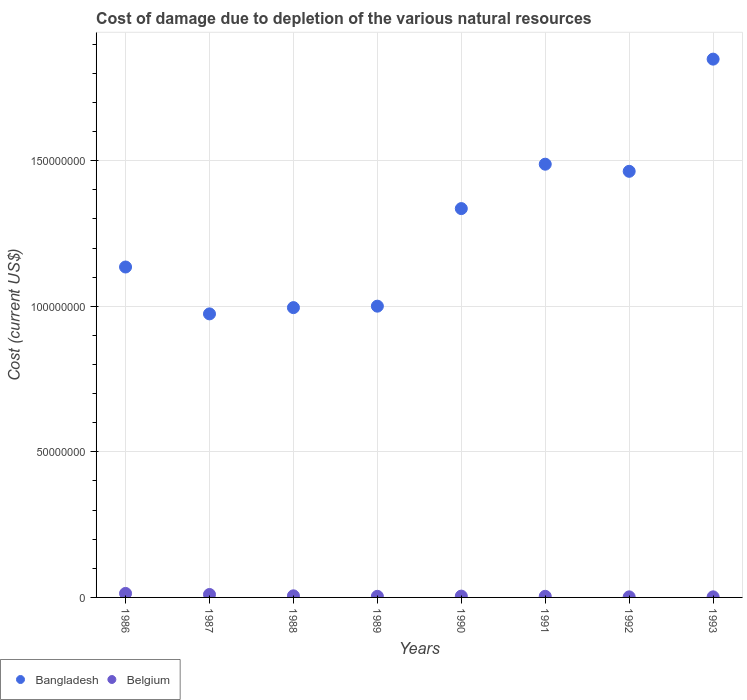How many different coloured dotlines are there?
Keep it short and to the point. 2. What is the cost of damage caused due to the depletion of various natural resources in Belgium in 1987?
Make the answer very short. 1.01e+06. Across all years, what is the maximum cost of damage caused due to the depletion of various natural resources in Belgium?
Your response must be concise. 1.37e+06. Across all years, what is the minimum cost of damage caused due to the depletion of various natural resources in Bangladesh?
Offer a very short reply. 9.74e+07. In which year was the cost of damage caused due to the depletion of various natural resources in Bangladesh maximum?
Your answer should be compact. 1993. What is the total cost of damage caused due to the depletion of various natural resources in Belgium in the graph?
Give a very brief answer. 4.54e+06. What is the difference between the cost of damage caused due to the depletion of various natural resources in Bangladesh in 1990 and that in 1992?
Make the answer very short. -1.28e+07. What is the difference between the cost of damage caused due to the depletion of various natural resources in Bangladesh in 1988 and the cost of damage caused due to the depletion of various natural resources in Belgium in 1987?
Make the answer very short. 9.85e+07. What is the average cost of damage caused due to the depletion of various natural resources in Belgium per year?
Your answer should be very brief. 5.68e+05. In the year 1987, what is the difference between the cost of damage caused due to the depletion of various natural resources in Bangladesh and cost of damage caused due to the depletion of various natural resources in Belgium?
Offer a very short reply. 9.64e+07. In how many years, is the cost of damage caused due to the depletion of various natural resources in Belgium greater than 170000000 US$?
Provide a short and direct response. 0. What is the ratio of the cost of damage caused due to the depletion of various natural resources in Bangladesh in 1986 to that in 1988?
Give a very brief answer. 1.14. Is the difference between the cost of damage caused due to the depletion of various natural resources in Bangladesh in 1991 and 1992 greater than the difference between the cost of damage caused due to the depletion of various natural resources in Belgium in 1991 and 1992?
Ensure brevity in your answer.  Yes. What is the difference between the highest and the second highest cost of damage caused due to the depletion of various natural resources in Bangladesh?
Keep it short and to the point. 3.61e+07. What is the difference between the highest and the lowest cost of damage caused due to the depletion of various natural resources in Bangladesh?
Your answer should be compact. 8.75e+07. In how many years, is the cost of damage caused due to the depletion of various natural resources in Belgium greater than the average cost of damage caused due to the depletion of various natural resources in Belgium taken over all years?
Give a very brief answer. 2. Is the sum of the cost of damage caused due to the depletion of various natural resources in Bangladesh in 1986 and 1987 greater than the maximum cost of damage caused due to the depletion of various natural resources in Belgium across all years?
Provide a short and direct response. Yes. Does the cost of damage caused due to the depletion of various natural resources in Bangladesh monotonically increase over the years?
Your answer should be very brief. No. What is the difference between two consecutive major ticks on the Y-axis?
Offer a very short reply. 5.00e+07. Are the values on the major ticks of Y-axis written in scientific E-notation?
Provide a succinct answer. No. What is the title of the graph?
Your answer should be compact. Cost of damage due to depletion of the various natural resources. What is the label or title of the X-axis?
Your response must be concise. Years. What is the label or title of the Y-axis?
Make the answer very short. Cost (current US$). What is the Cost (current US$) in Bangladesh in 1986?
Keep it short and to the point. 1.13e+08. What is the Cost (current US$) in Belgium in 1986?
Your answer should be very brief. 1.37e+06. What is the Cost (current US$) of Bangladesh in 1987?
Your answer should be compact. 9.74e+07. What is the Cost (current US$) in Belgium in 1987?
Ensure brevity in your answer.  1.01e+06. What is the Cost (current US$) of Bangladesh in 1988?
Give a very brief answer. 9.95e+07. What is the Cost (current US$) of Belgium in 1988?
Provide a succinct answer. 5.48e+05. What is the Cost (current US$) of Bangladesh in 1989?
Provide a succinct answer. 1.00e+08. What is the Cost (current US$) in Belgium in 1989?
Offer a very short reply. 3.83e+05. What is the Cost (current US$) in Bangladesh in 1990?
Your answer should be very brief. 1.34e+08. What is the Cost (current US$) in Belgium in 1990?
Your response must be concise. 4.52e+05. What is the Cost (current US$) of Bangladesh in 1991?
Make the answer very short. 1.49e+08. What is the Cost (current US$) of Belgium in 1991?
Keep it short and to the point. 3.84e+05. What is the Cost (current US$) of Bangladesh in 1992?
Your response must be concise. 1.46e+08. What is the Cost (current US$) in Belgium in 1992?
Provide a succinct answer. 1.95e+05. What is the Cost (current US$) of Bangladesh in 1993?
Make the answer very short. 1.85e+08. What is the Cost (current US$) of Belgium in 1993?
Keep it short and to the point. 1.97e+05. Across all years, what is the maximum Cost (current US$) of Bangladesh?
Your response must be concise. 1.85e+08. Across all years, what is the maximum Cost (current US$) in Belgium?
Provide a short and direct response. 1.37e+06. Across all years, what is the minimum Cost (current US$) in Bangladesh?
Keep it short and to the point. 9.74e+07. Across all years, what is the minimum Cost (current US$) in Belgium?
Provide a succinct answer. 1.95e+05. What is the total Cost (current US$) of Bangladesh in the graph?
Provide a short and direct response. 1.02e+09. What is the total Cost (current US$) in Belgium in the graph?
Provide a short and direct response. 4.54e+06. What is the difference between the Cost (current US$) in Bangladesh in 1986 and that in 1987?
Ensure brevity in your answer.  1.61e+07. What is the difference between the Cost (current US$) of Belgium in 1986 and that in 1987?
Offer a terse response. 3.66e+05. What is the difference between the Cost (current US$) in Bangladesh in 1986 and that in 1988?
Offer a terse response. 1.40e+07. What is the difference between the Cost (current US$) of Belgium in 1986 and that in 1988?
Provide a short and direct response. 8.26e+05. What is the difference between the Cost (current US$) in Bangladesh in 1986 and that in 1989?
Ensure brevity in your answer.  1.34e+07. What is the difference between the Cost (current US$) of Belgium in 1986 and that in 1989?
Provide a succinct answer. 9.91e+05. What is the difference between the Cost (current US$) of Bangladesh in 1986 and that in 1990?
Offer a very short reply. -2.01e+07. What is the difference between the Cost (current US$) in Belgium in 1986 and that in 1990?
Your answer should be very brief. 9.23e+05. What is the difference between the Cost (current US$) of Bangladesh in 1986 and that in 1991?
Make the answer very short. -3.53e+07. What is the difference between the Cost (current US$) in Belgium in 1986 and that in 1991?
Your answer should be very brief. 9.91e+05. What is the difference between the Cost (current US$) in Bangladesh in 1986 and that in 1992?
Keep it short and to the point. -3.29e+07. What is the difference between the Cost (current US$) in Belgium in 1986 and that in 1992?
Provide a succinct answer. 1.18e+06. What is the difference between the Cost (current US$) of Bangladesh in 1986 and that in 1993?
Provide a short and direct response. -7.14e+07. What is the difference between the Cost (current US$) in Belgium in 1986 and that in 1993?
Make the answer very short. 1.18e+06. What is the difference between the Cost (current US$) of Bangladesh in 1987 and that in 1988?
Your answer should be compact. -2.15e+06. What is the difference between the Cost (current US$) of Belgium in 1987 and that in 1988?
Your answer should be very brief. 4.60e+05. What is the difference between the Cost (current US$) in Bangladesh in 1987 and that in 1989?
Your answer should be compact. -2.65e+06. What is the difference between the Cost (current US$) in Belgium in 1987 and that in 1989?
Provide a succinct answer. 6.25e+05. What is the difference between the Cost (current US$) in Bangladesh in 1987 and that in 1990?
Provide a short and direct response. -3.62e+07. What is the difference between the Cost (current US$) of Belgium in 1987 and that in 1990?
Offer a terse response. 5.57e+05. What is the difference between the Cost (current US$) in Bangladesh in 1987 and that in 1991?
Give a very brief answer. -5.14e+07. What is the difference between the Cost (current US$) of Belgium in 1987 and that in 1991?
Provide a short and direct response. 6.25e+05. What is the difference between the Cost (current US$) of Bangladesh in 1987 and that in 1992?
Your response must be concise. -4.90e+07. What is the difference between the Cost (current US$) of Belgium in 1987 and that in 1992?
Your answer should be very brief. 8.14e+05. What is the difference between the Cost (current US$) of Bangladesh in 1987 and that in 1993?
Ensure brevity in your answer.  -8.75e+07. What is the difference between the Cost (current US$) in Belgium in 1987 and that in 1993?
Your response must be concise. 8.11e+05. What is the difference between the Cost (current US$) in Bangladesh in 1988 and that in 1989?
Offer a very short reply. -5.01e+05. What is the difference between the Cost (current US$) of Belgium in 1988 and that in 1989?
Your answer should be compact. 1.65e+05. What is the difference between the Cost (current US$) in Bangladesh in 1988 and that in 1990?
Provide a succinct answer. -3.40e+07. What is the difference between the Cost (current US$) of Belgium in 1988 and that in 1990?
Offer a terse response. 9.63e+04. What is the difference between the Cost (current US$) in Bangladesh in 1988 and that in 1991?
Give a very brief answer. -4.93e+07. What is the difference between the Cost (current US$) in Belgium in 1988 and that in 1991?
Keep it short and to the point. 1.64e+05. What is the difference between the Cost (current US$) in Bangladesh in 1988 and that in 1992?
Your answer should be compact. -4.68e+07. What is the difference between the Cost (current US$) of Belgium in 1988 and that in 1992?
Provide a short and direct response. 3.53e+05. What is the difference between the Cost (current US$) of Bangladesh in 1988 and that in 1993?
Offer a terse response. -8.54e+07. What is the difference between the Cost (current US$) in Belgium in 1988 and that in 1993?
Provide a succinct answer. 3.51e+05. What is the difference between the Cost (current US$) of Bangladesh in 1989 and that in 1990?
Your answer should be very brief. -3.35e+07. What is the difference between the Cost (current US$) of Belgium in 1989 and that in 1990?
Ensure brevity in your answer.  -6.87e+04. What is the difference between the Cost (current US$) of Bangladesh in 1989 and that in 1991?
Your answer should be compact. -4.88e+07. What is the difference between the Cost (current US$) of Belgium in 1989 and that in 1991?
Your response must be concise. -851.58. What is the difference between the Cost (current US$) of Bangladesh in 1989 and that in 1992?
Keep it short and to the point. -4.63e+07. What is the difference between the Cost (current US$) in Belgium in 1989 and that in 1992?
Give a very brief answer. 1.88e+05. What is the difference between the Cost (current US$) of Bangladesh in 1989 and that in 1993?
Offer a terse response. -8.49e+07. What is the difference between the Cost (current US$) of Belgium in 1989 and that in 1993?
Provide a succinct answer. 1.86e+05. What is the difference between the Cost (current US$) in Bangladesh in 1990 and that in 1991?
Provide a succinct answer. -1.52e+07. What is the difference between the Cost (current US$) in Belgium in 1990 and that in 1991?
Ensure brevity in your answer.  6.79e+04. What is the difference between the Cost (current US$) in Bangladesh in 1990 and that in 1992?
Give a very brief answer. -1.28e+07. What is the difference between the Cost (current US$) of Belgium in 1990 and that in 1992?
Give a very brief answer. 2.57e+05. What is the difference between the Cost (current US$) in Bangladesh in 1990 and that in 1993?
Offer a terse response. -5.13e+07. What is the difference between the Cost (current US$) in Belgium in 1990 and that in 1993?
Provide a short and direct response. 2.55e+05. What is the difference between the Cost (current US$) of Bangladesh in 1991 and that in 1992?
Give a very brief answer. 2.44e+06. What is the difference between the Cost (current US$) in Belgium in 1991 and that in 1992?
Offer a very short reply. 1.89e+05. What is the difference between the Cost (current US$) of Bangladesh in 1991 and that in 1993?
Provide a succinct answer. -3.61e+07. What is the difference between the Cost (current US$) of Belgium in 1991 and that in 1993?
Provide a succinct answer. 1.87e+05. What is the difference between the Cost (current US$) in Bangladesh in 1992 and that in 1993?
Ensure brevity in your answer.  -3.85e+07. What is the difference between the Cost (current US$) of Belgium in 1992 and that in 1993?
Give a very brief answer. -2462.86. What is the difference between the Cost (current US$) of Bangladesh in 1986 and the Cost (current US$) of Belgium in 1987?
Give a very brief answer. 1.12e+08. What is the difference between the Cost (current US$) in Bangladesh in 1986 and the Cost (current US$) in Belgium in 1988?
Provide a succinct answer. 1.13e+08. What is the difference between the Cost (current US$) of Bangladesh in 1986 and the Cost (current US$) of Belgium in 1989?
Offer a terse response. 1.13e+08. What is the difference between the Cost (current US$) in Bangladesh in 1986 and the Cost (current US$) in Belgium in 1990?
Ensure brevity in your answer.  1.13e+08. What is the difference between the Cost (current US$) in Bangladesh in 1986 and the Cost (current US$) in Belgium in 1991?
Offer a very short reply. 1.13e+08. What is the difference between the Cost (current US$) in Bangladesh in 1986 and the Cost (current US$) in Belgium in 1992?
Your response must be concise. 1.13e+08. What is the difference between the Cost (current US$) in Bangladesh in 1986 and the Cost (current US$) in Belgium in 1993?
Give a very brief answer. 1.13e+08. What is the difference between the Cost (current US$) of Bangladesh in 1987 and the Cost (current US$) of Belgium in 1988?
Your answer should be compact. 9.69e+07. What is the difference between the Cost (current US$) in Bangladesh in 1987 and the Cost (current US$) in Belgium in 1989?
Offer a very short reply. 9.70e+07. What is the difference between the Cost (current US$) of Bangladesh in 1987 and the Cost (current US$) of Belgium in 1990?
Provide a succinct answer. 9.69e+07. What is the difference between the Cost (current US$) of Bangladesh in 1987 and the Cost (current US$) of Belgium in 1991?
Provide a succinct answer. 9.70e+07. What is the difference between the Cost (current US$) in Bangladesh in 1987 and the Cost (current US$) in Belgium in 1992?
Offer a terse response. 9.72e+07. What is the difference between the Cost (current US$) in Bangladesh in 1987 and the Cost (current US$) in Belgium in 1993?
Ensure brevity in your answer.  9.72e+07. What is the difference between the Cost (current US$) in Bangladesh in 1988 and the Cost (current US$) in Belgium in 1989?
Your answer should be compact. 9.92e+07. What is the difference between the Cost (current US$) of Bangladesh in 1988 and the Cost (current US$) of Belgium in 1990?
Provide a succinct answer. 9.91e+07. What is the difference between the Cost (current US$) in Bangladesh in 1988 and the Cost (current US$) in Belgium in 1991?
Provide a short and direct response. 9.92e+07. What is the difference between the Cost (current US$) of Bangladesh in 1988 and the Cost (current US$) of Belgium in 1992?
Your answer should be compact. 9.94e+07. What is the difference between the Cost (current US$) in Bangladesh in 1988 and the Cost (current US$) in Belgium in 1993?
Provide a short and direct response. 9.94e+07. What is the difference between the Cost (current US$) in Bangladesh in 1989 and the Cost (current US$) in Belgium in 1990?
Offer a terse response. 9.96e+07. What is the difference between the Cost (current US$) of Bangladesh in 1989 and the Cost (current US$) of Belgium in 1991?
Offer a terse response. 9.97e+07. What is the difference between the Cost (current US$) of Bangladesh in 1989 and the Cost (current US$) of Belgium in 1992?
Your answer should be very brief. 9.99e+07. What is the difference between the Cost (current US$) of Bangladesh in 1989 and the Cost (current US$) of Belgium in 1993?
Keep it short and to the point. 9.99e+07. What is the difference between the Cost (current US$) of Bangladesh in 1990 and the Cost (current US$) of Belgium in 1991?
Offer a very short reply. 1.33e+08. What is the difference between the Cost (current US$) in Bangladesh in 1990 and the Cost (current US$) in Belgium in 1992?
Provide a short and direct response. 1.33e+08. What is the difference between the Cost (current US$) of Bangladesh in 1990 and the Cost (current US$) of Belgium in 1993?
Offer a terse response. 1.33e+08. What is the difference between the Cost (current US$) of Bangladesh in 1991 and the Cost (current US$) of Belgium in 1992?
Make the answer very short. 1.49e+08. What is the difference between the Cost (current US$) of Bangladesh in 1991 and the Cost (current US$) of Belgium in 1993?
Your answer should be compact. 1.49e+08. What is the difference between the Cost (current US$) in Bangladesh in 1992 and the Cost (current US$) in Belgium in 1993?
Offer a terse response. 1.46e+08. What is the average Cost (current US$) in Bangladesh per year?
Give a very brief answer. 1.28e+08. What is the average Cost (current US$) in Belgium per year?
Keep it short and to the point. 5.68e+05. In the year 1986, what is the difference between the Cost (current US$) in Bangladesh and Cost (current US$) in Belgium?
Give a very brief answer. 1.12e+08. In the year 1987, what is the difference between the Cost (current US$) in Bangladesh and Cost (current US$) in Belgium?
Provide a short and direct response. 9.64e+07. In the year 1988, what is the difference between the Cost (current US$) in Bangladesh and Cost (current US$) in Belgium?
Offer a very short reply. 9.90e+07. In the year 1989, what is the difference between the Cost (current US$) of Bangladesh and Cost (current US$) of Belgium?
Make the answer very short. 9.97e+07. In the year 1990, what is the difference between the Cost (current US$) of Bangladesh and Cost (current US$) of Belgium?
Offer a very short reply. 1.33e+08. In the year 1991, what is the difference between the Cost (current US$) in Bangladesh and Cost (current US$) in Belgium?
Offer a very short reply. 1.48e+08. In the year 1992, what is the difference between the Cost (current US$) in Bangladesh and Cost (current US$) in Belgium?
Provide a succinct answer. 1.46e+08. In the year 1993, what is the difference between the Cost (current US$) of Bangladesh and Cost (current US$) of Belgium?
Ensure brevity in your answer.  1.85e+08. What is the ratio of the Cost (current US$) in Bangladesh in 1986 to that in 1987?
Give a very brief answer. 1.17. What is the ratio of the Cost (current US$) of Belgium in 1986 to that in 1987?
Provide a succinct answer. 1.36. What is the ratio of the Cost (current US$) of Bangladesh in 1986 to that in 1988?
Provide a succinct answer. 1.14. What is the ratio of the Cost (current US$) in Belgium in 1986 to that in 1988?
Your response must be concise. 2.51. What is the ratio of the Cost (current US$) of Bangladesh in 1986 to that in 1989?
Your answer should be very brief. 1.13. What is the ratio of the Cost (current US$) of Belgium in 1986 to that in 1989?
Your answer should be compact. 3.59. What is the ratio of the Cost (current US$) in Bangladesh in 1986 to that in 1990?
Provide a short and direct response. 0.85. What is the ratio of the Cost (current US$) in Belgium in 1986 to that in 1990?
Your response must be concise. 3.04. What is the ratio of the Cost (current US$) in Bangladesh in 1986 to that in 1991?
Offer a very short reply. 0.76. What is the ratio of the Cost (current US$) of Belgium in 1986 to that in 1991?
Offer a terse response. 3.58. What is the ratio of the Cost (current US$) in Bangladesh in 1986 to that in 1992?
Give a very brief answer. 0.78. What is the ratio of the Cost (current US$) in Belgium in 1986 to that in 1992?
Make the answer very short. 7.06. What is the ratio of the Cost (current US$) in Bangladesh in 1986 to that in 1993?
Your answer should be compact. 0.61. What is the ratio of the Cost (current US$) of Belgium in 1986 to that in 1993?
Your answer should be compact. 6.97. What is the ratio of the Cost (current US$) in Bangladesh in 1987 to that in 1988?
Your answer should be very brief. 0.98. What is the ratio of the Cost (current US$) in Belgium in 1987 to that in 1988?
Provide a succinct answer. 1.84. What is the ratio of the Cost (current US$) of Bangladesh in 1987 to that in 1989?
Your answer should be very brief. 0.97. What is the ratio of the Cost (current US$) in Belgium in 1987 to that in 1989?
Offer a terse response. 2.63. What is the ratio of the Cost (current US$) in Bangladesh in 1987 to that in 1990?
Your answer should be very brief. 0.73. What is the ratio of the Cost (current US$) in Belgium in 1987 to that in 1990?
Give a very brief answer. 2.23. What is the ratio of the Cost (current US$) of Bangladesh in 1987 to that in 1991?
Your answer should be very brief. 0.65. What is the ratio of the Cost (current US$) of Belgium in 1987 to that in 1991?
Make the answer very short. 2.63. What is the ratio of the Cost (current US$) of Bangladesh in 1987 to that in 1992?
Offer a terse response. 0.67. What is the ratio of the Cost (current US$) in Belgium in 1987 to that in 1992?
Offer a very short reply. 5.18. What is the ratio of the Cost (current US$) of Bangladesh in 1987 to that in 1993?
Your answer should be very brief. 0.53. What is the ratio of the Cost (current US$) of Belgium in 1987 to that in 1993?
Ensure brevity in your answer.  5.11. What is the ratio of the Cost (current US$) of Belgium in 1988 to that in 1989?
Make the answer very short. 1.43. What is the ratio of the Cost (current US$) of Bangladesh in 1988 to that in 1990?
Provide a succinct answer. 0.75. What is the ratio of the Cost (current US$) of Belgium in 1988 to that in 1990?
Give a very brief answer. 1.21. What is the ratio of the Cost (current US$) in Bangladesh in 1988 to that in 1991?
Your answer should be very brief. 0.67. What is the ratio of the Cost (current US$) in Belgium in 1988 to that in 1991?
Offer a terse response. 1.43. What is the ratio of the Cost (current US$) of Bangladesh in 1988 to that in 1992?
Your answer should be very brief. 0.68. What is the ratio of the Cost (current US$) in Belgium in 1988 to that in 1992?
Make the answer very short. 2.81. What is the ratio of the Cost (current US$) in Bangladesh in 1988 to that in 1993?
Ensure brevity in your answer.  0.54. What is the ratio of the Cost (current US$) in Belgium in 1988 to that in 1993?
Your answer should be very brief. 2.78. What is the ratio of the Cost (current US$) in Bangladesh in 1989 to that in 1990?
Make the answer very short. 0.75. What is the ratio of the Cost (current US$) of Belgium in 1989 to that in 1990?
Keep it short and to the point. 0.85. What is the ratio of the Cost (current US$) in Bangladesh in 1989 to that in 1991?
Your answer should be very brief. 0.67. What is the ratio of the Cost (current US$) in Belgium in 1989 to that in 1991?
Provide a succinct answer. 1. What is the ratio of the Cost (current US$) of Bangladesh in 1989 to that in 1992?
Make the answer very short. 0.68. What is the ratio of the Cost (current US$) in Belgium in 1989 to that in 1992?
Keep it short and to the point. 1.97. What is the ratio of the Cost (current US$) in Bangladesh in 1989 to that in 1993?
Provide a succinct answer. 0.54. What is the ratio of the Cost (current US$) of Belgium in 1989 to that in 1993?
Keep it short and to the point. 1.94. What is the ratio of the Cost (current US$) in Bangladesh in 1990 to that in 1991?
Your answer should be very brief. 0.9. What is the ratio of the Cost (current US$) in Belgium in 1990 to that in 1991?
Offer a very short reply. 1.18. What is the ratio of the Cost (current US$) in Bangladesh in 1990 to that in 1992?
Make the answer very short. 0.91. What is the ratio of the Cost (current US$) of Belgium in 1990 to that in 1992?
Your answer should be compact. 2.32. What is the ratio of the Cost (current US$) in Bangladesh in 1990 to that in 1993?
Provide a short and direct response. 0.72. What is the ratio of the Cost (current US$) of Belgium in 1990 to that in 1993?
Your response must be concise. 2.29. What is the ratio of the Cost (current US$) in Bangladesh in 1991 to that in 1992?
Offer a very short reply. 1.02. What is the ratio of the Cost (current US$) in Belgium in 1991 to that in 1992?
Offer a very short reply. 1.97. What is the ratio of the Cost (current US$) in Bangladesh in 1991 to that in 1993?
Your answer should be compact. 0.8. What is the ratio of the Cost (current US$) of Belgium in 1991 to that in 1993?
Give a very brief answer. 1.95. What is the ratio of the Cost (current US$) in Bangladesh in 1992 to that in 1993?
Offer a terse response. 0.79. What is the ratio of the Cost (current US$) of Belgium in 1992 to that in 1993?
Offer a terse response. 0.99. What is the difference between the highest and the second highest Cost (current US$) of Bangladesh?
Offer a terse response. 3.61e+07. What is the difference between the highest and the second highest Cost (current US$) in Belgium?
Offer a terse response. 3.66e+05. What is the difference between the highest and the lowest Cost (current US$) of Bangladesh?
Your response must be concise. 8.75e+07. What is the difference between the highest and the lowest Cost (current US$) of Belgium?
Give a very brief answer. 1.18e+06. 